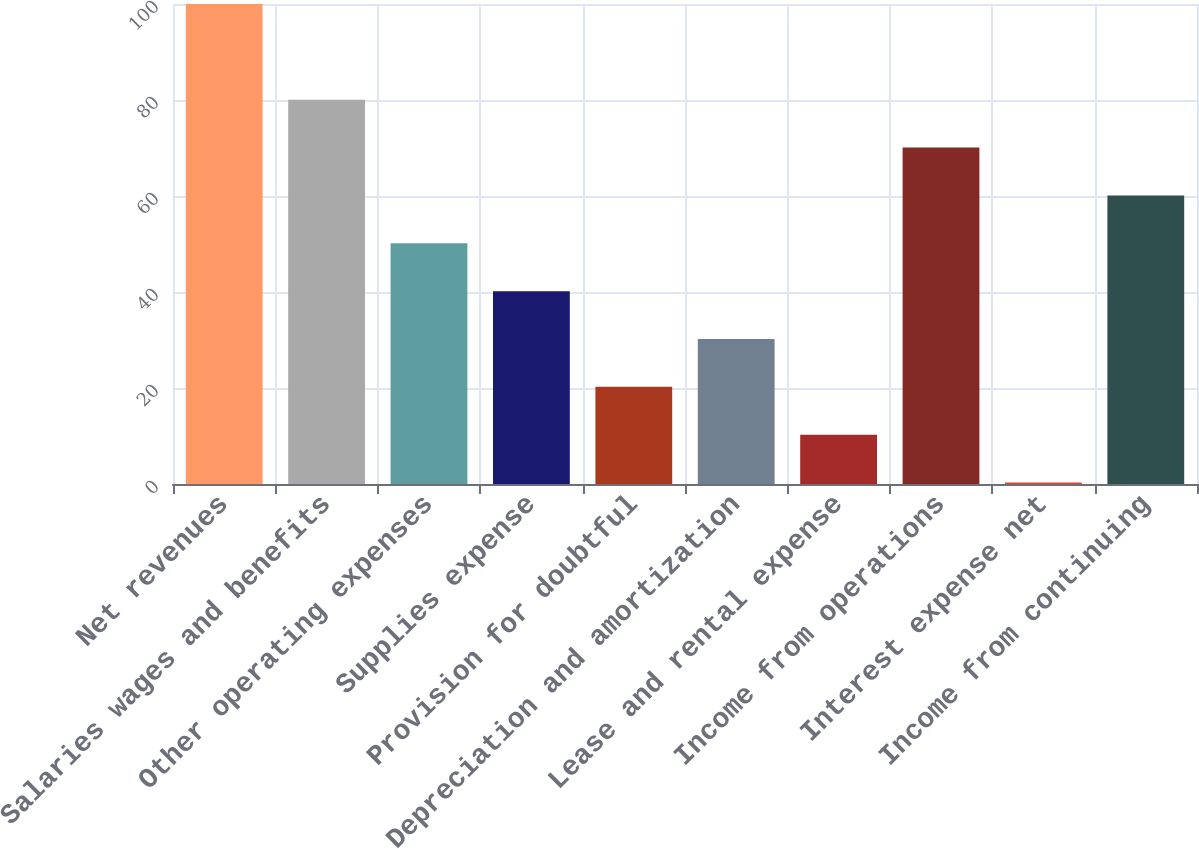<chart> <loc_0><loc_0><loc_500><loc_500><bar_chart><fcel>Net revenues<fcel>Salaries wages and benefits<fcel>Other operating expenses<fcel>Supplies expense<fcel>Provision for doubtful<fcel>Depreciation and amortization<fcel>Lease and rental expense<fcel>Income from operations<fcel>Interest expense net<fcel>Income from continuing<nl><fcel>100<fcel>80.06<fcel>50.15<fcel>40.18<fcel>20.24<fcel>30.21<fcel>10.27<fcel>70.09<fcel>0.3<fcel>60.12<nl></chart> 